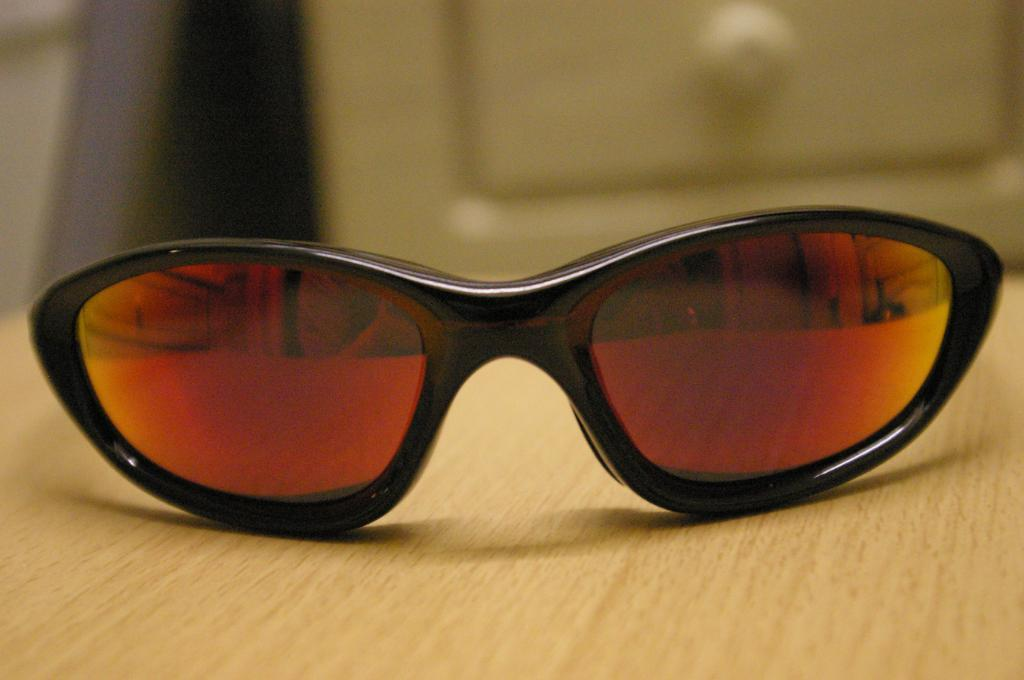What object is placed on the table in the image? There are spectacles on a table in the image. Can you describe the background of the image? The background of the image is blurry. What type of unit is being measured in the image? There is no indication of any unit being measured in the image. What list can be seen in the image? There is no list present in the image. 